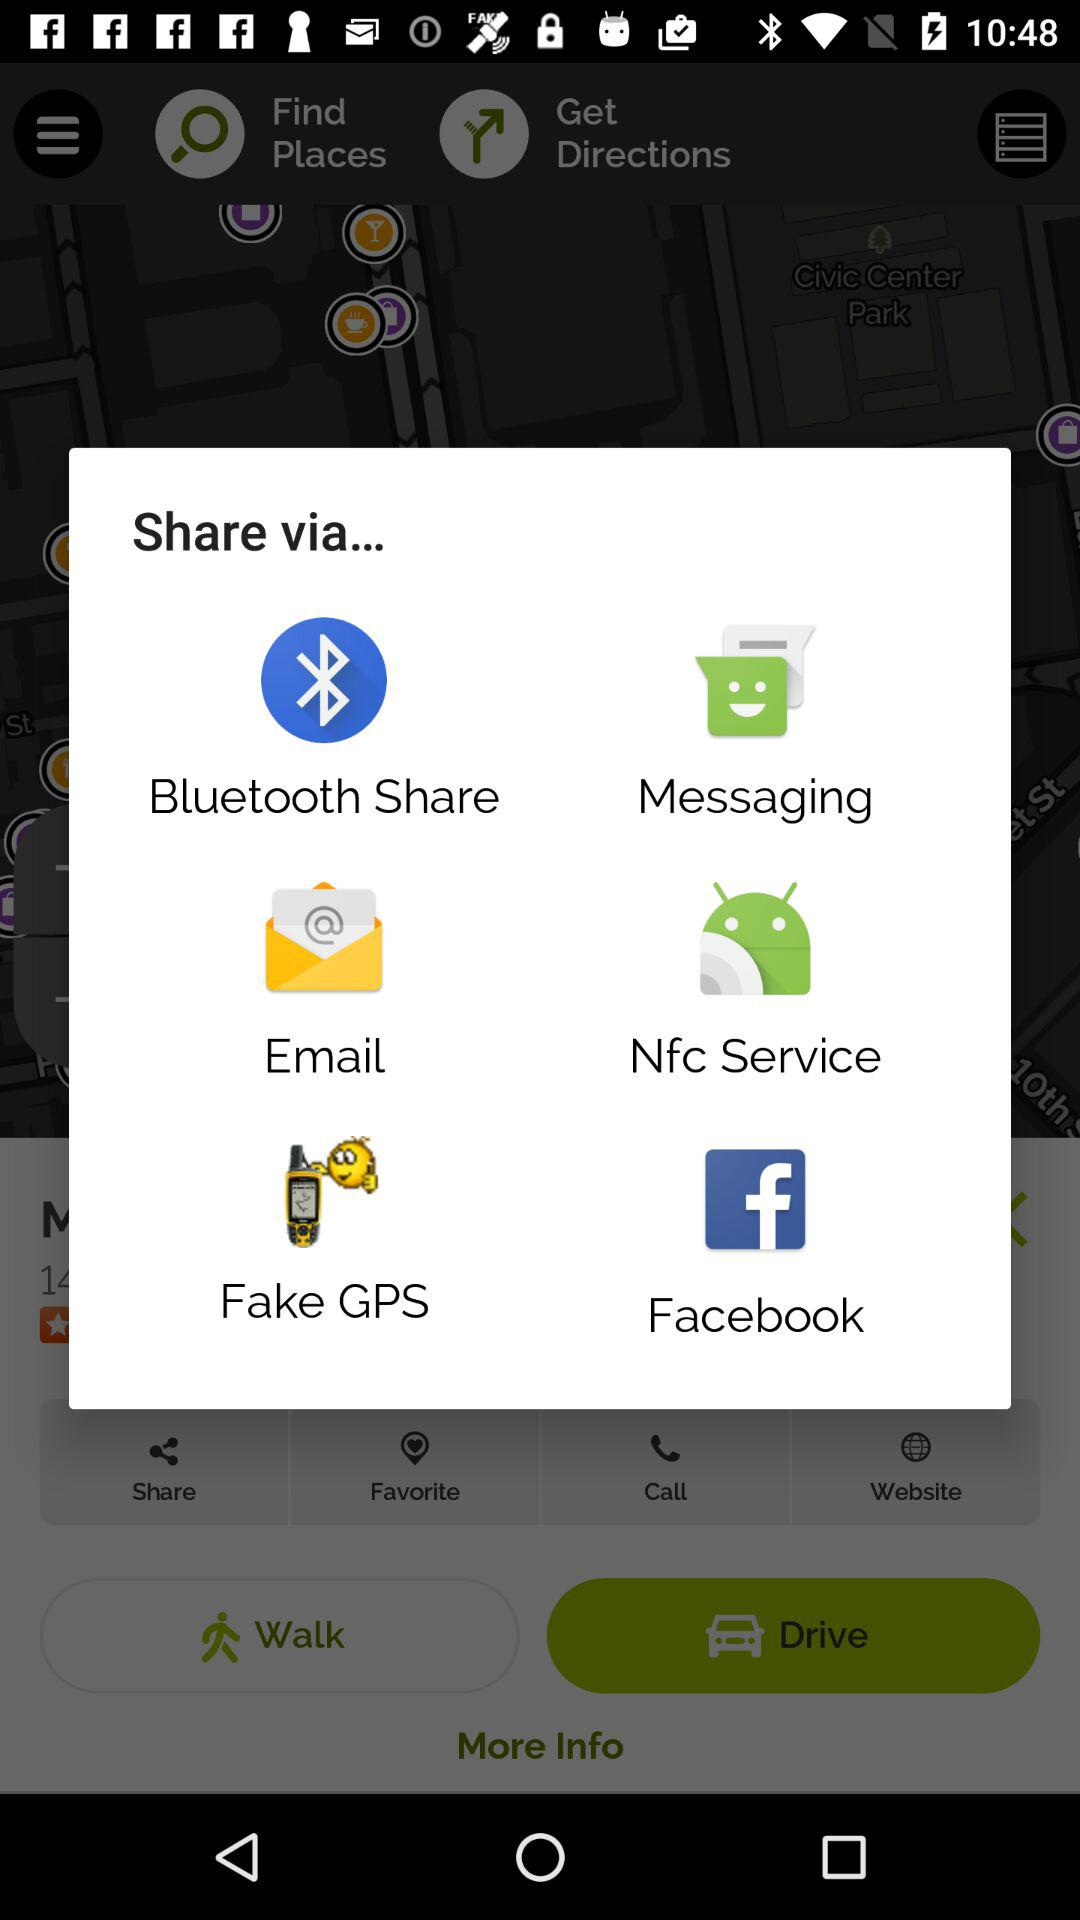What are the sharing options? The sharing options are "Bluetooth Share", "Messaging", "Email", "Nfc Service", "Fake GPS" and "Facebook". 